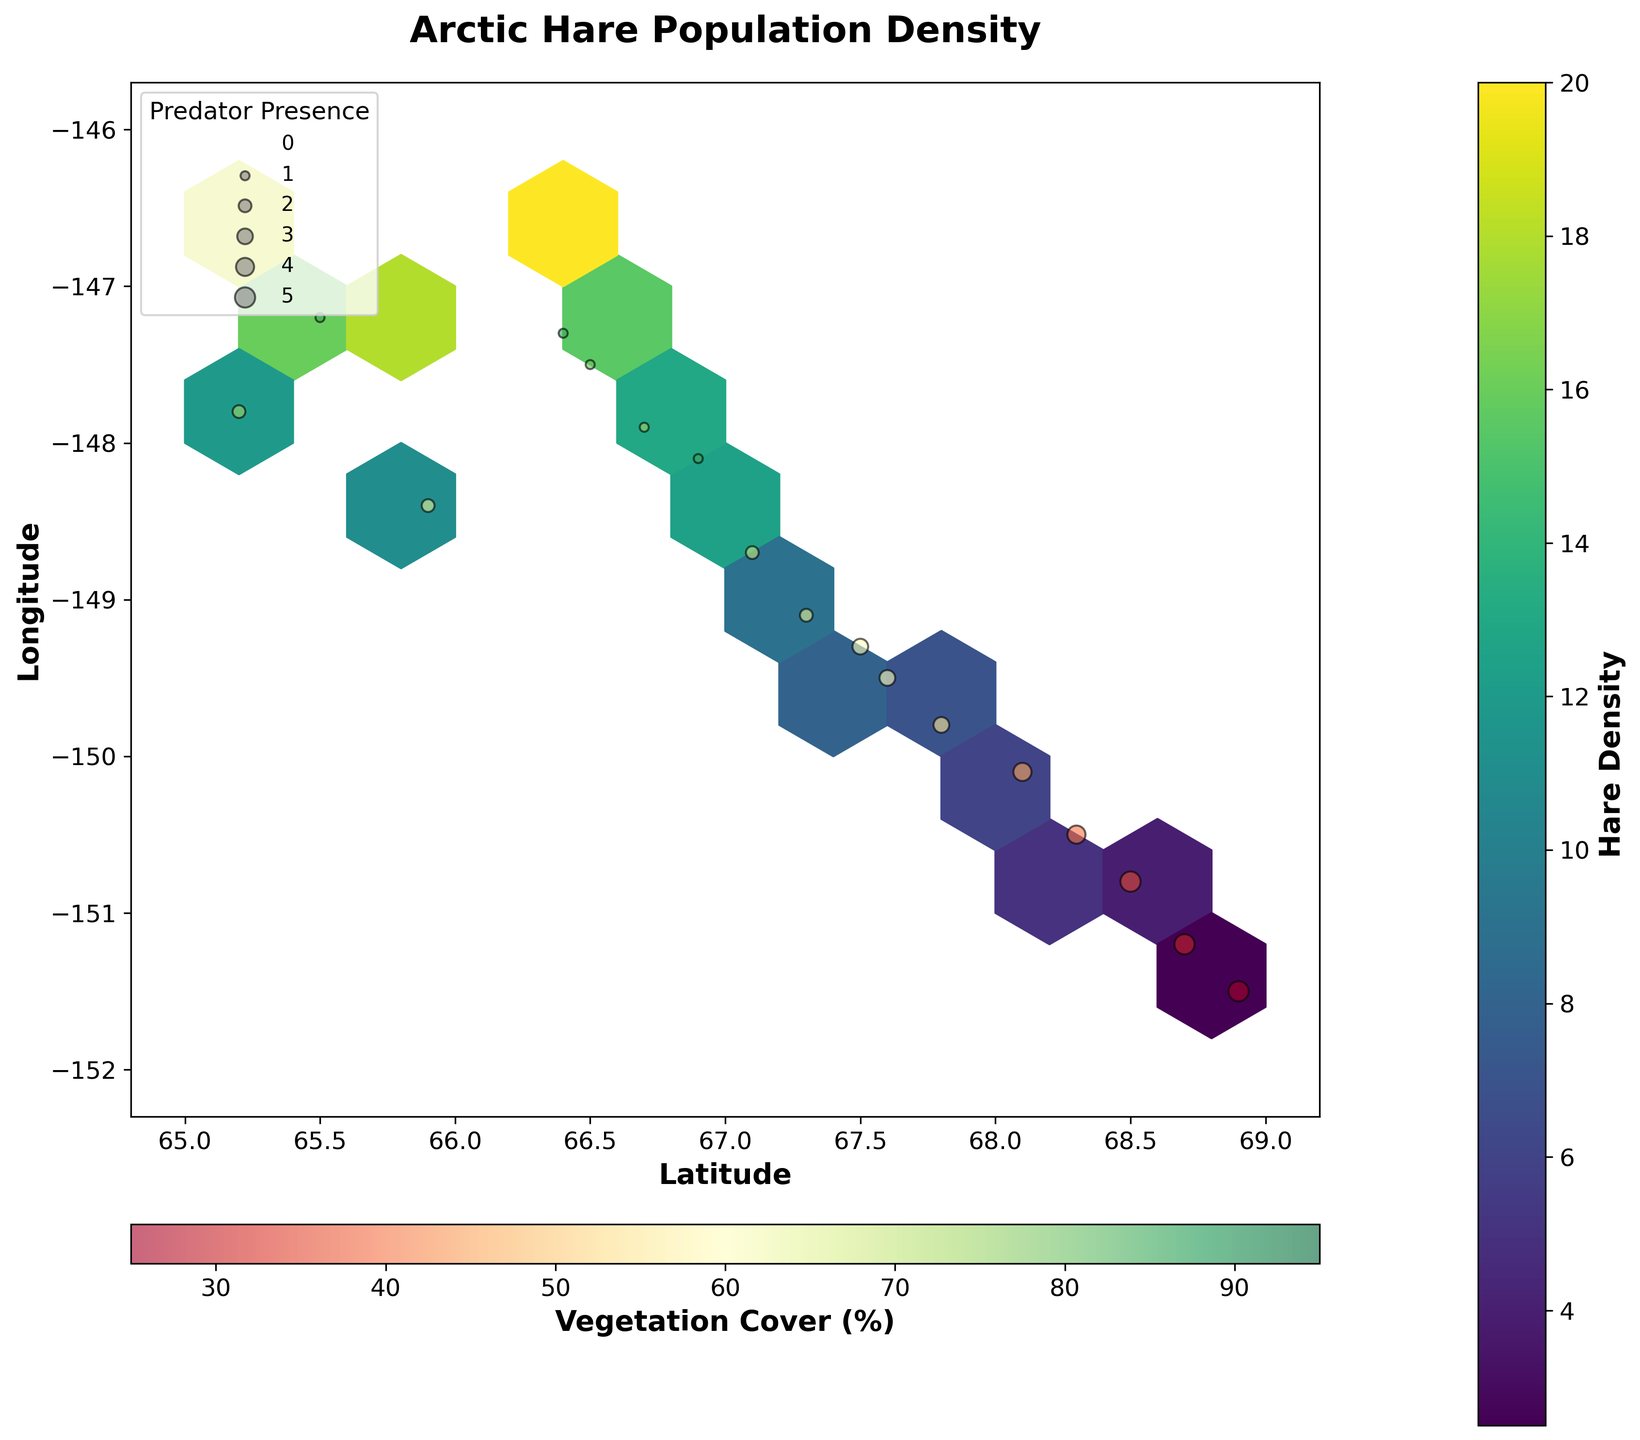What is the title of the plot? The title can be found at the top of the plot.
Answer: Arctic Hare Population Density What do the colors of the hexagons represent? The color scale on the side of the plot labeled 'Hare Density' indicates that the colors represent the density of hare populations.
Answer: Hare density What do the different marker sizes represent? There is a legend in the plot that indicates the marker size represents predator presence, with larger markers indicating higher predator presence.
Answer: Predator presence Which area has the highest hare density? By examining the hexagons' colors and referring to the color bar, the hexagon with the highest density is the brightest one, located approximately at coordinates (66.2, -146.8).
Answer: Around coordinates (66.2, -146.8) How is vegetation cover represented in the plot? Vegetation cover is mapped to the color of the scatter points, as indicated by the color bar labeled 'Vegetation Cover (%)' at the bottom of the plot. A higher percentage is represented by green colors.
Answer: Color of scatter points What can you infer about areas with high vegetation cover and hare density? By observing the scatter points colored green to yellow within brightly colored hexagons, those areas show higher hare density. Hence, higher vegetation cover generally corresponds to higher hare density.
Answer: High vegetation cover, high hare density Is there any area with no predator presence? The plotting area can be checked for the smallest marker sizes. A few points with a size close to zero, like around coordinates (65.8, -146.9), suggest no predator presence there.
Answer: Around coordinates (65.8, -146.9) How does predator presence affect hare density? By comparing regions with large markers (high predator presence) and their hexagon colors, high predator presence areas often have lower hare density, indicating an inverse relationship.
Answer: Higher predator presence, lower hare density Which coordinates have the greatest difference in hare density? Comparing hexagons across coordinates shows the brightest hexagon at (~66.2, -146.8) and the darkest at (~68.9, -151.5). The greatest difference is between these two points.
Answer: Coordinates (~66.2, -146.8) and (~68.9, -151.5) 